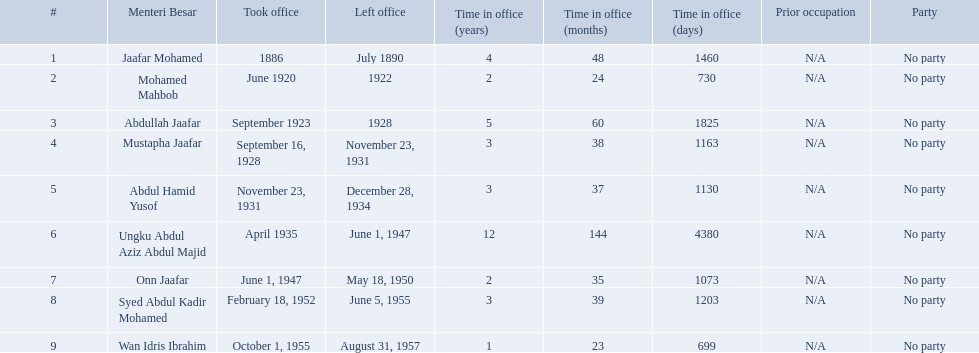Who were the menteri besar of johor? Jaafar Mohamed, Mohamed Mahbob, Abdullah Jaafar, Mustapha Jaafar, Abdul Hamid Yusof, Ungku Abdul Aziz Abdul Majid, Onn Jaafar, Syed Abdul Kadir Mohamed, Wan Idris Ibrahim. Who served the longest? Ungku Abdul Aziz Abdul Majid. Who are all of the menteri besars? Jaafar Mohamed, Mohamed Mahbob, Abdullah Jaafar, Mustapha Jaafar, Abdul Hamid Yusof, Ungku Abdul Aziz Abdul Majid, Onn Jaafar, Syed Abdul Kadir Mohamed, Wan Idris Ibrahim. When did each take office? 1886, June 1920, September 1923, September 16, 1928, November 23, 1931, April 1935, June 1, 1947, February 18, 1952, October 1, 1955. When did they leave? July 1890, 1922, 1928, November 23, 1931, December 28, 1934, June 1, 1947, May 18, 1950, June 5, 1955, August 31, 1957. And which spent the most time in office? Ungku Abdul Aziz Abdul Majid. 